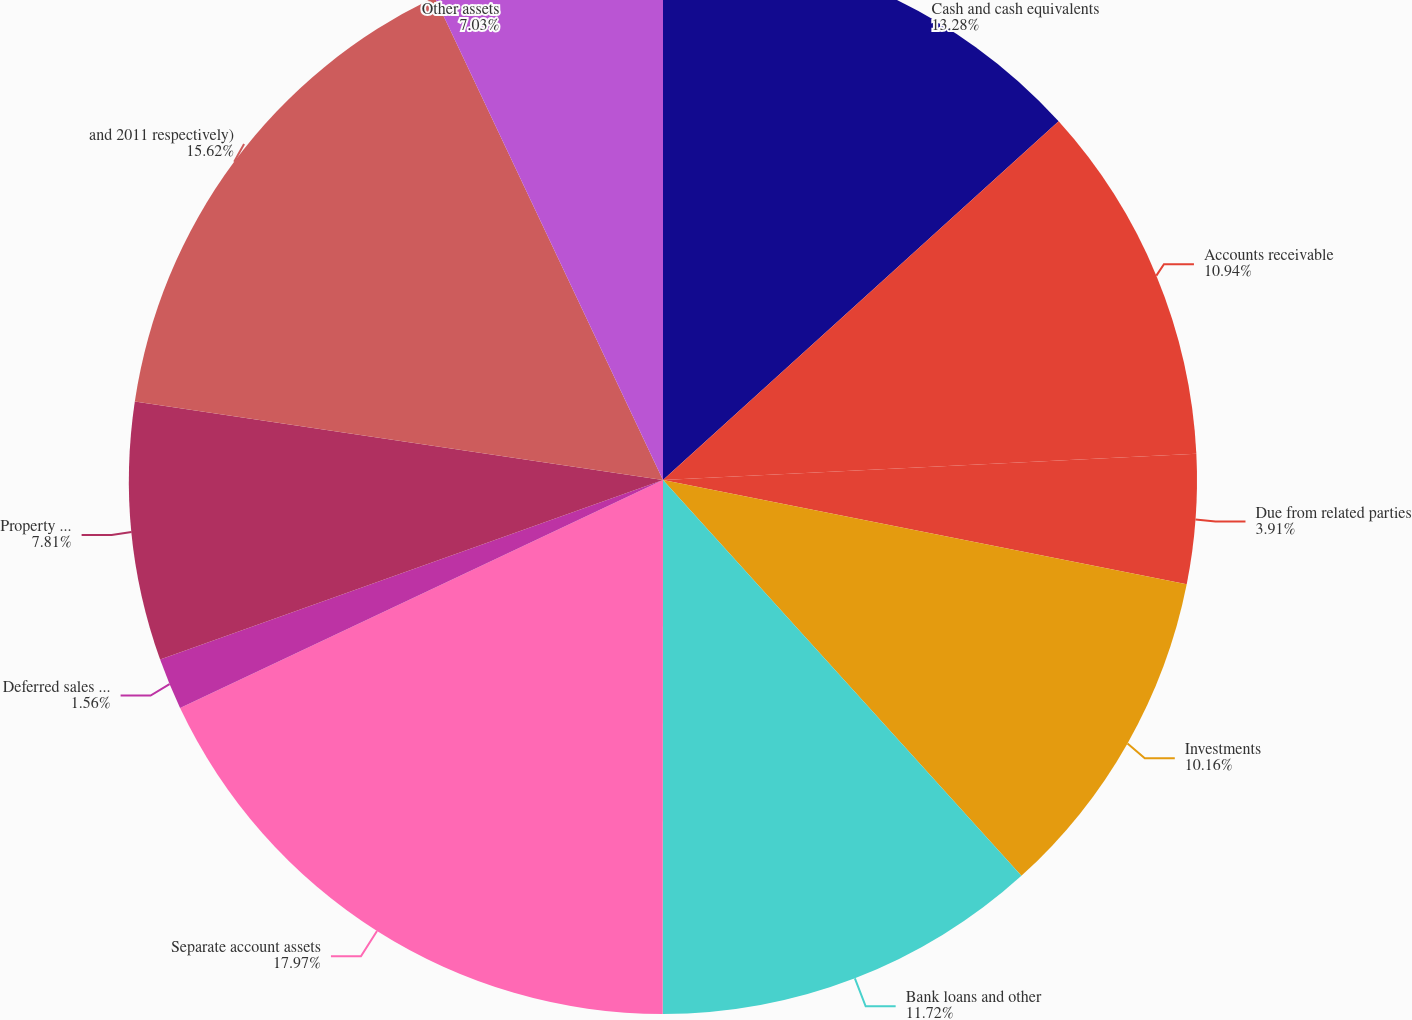Convert chart to OTSL. <chart><loc_0><loc_0><loc_500><loc_500><pie_chart><fcel>Cash and cash equivalents<fcel>Accounts receivable<fcel>Due from related parties<fcel>Investments<fcel>Bank loans and other<fcel>Separate account assets<fcel>Deferred sales commissions net<fcel>Property and equipment (net of<fcel>and 2011 respectively)<fcel>Other assets<nl><fcel>13.28%<fcel>10.94%<fcel>3.91%<fcel>10.16%<fcel>11.72%<fcel>17.97%<fcel>1.56%<fcel>7.81%<fcel>15.62%<fcel>7.03%<nl></chart> 